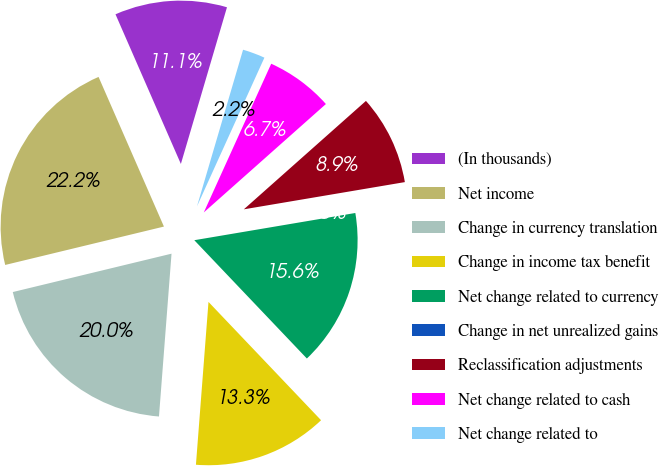Convert chart to OTSL. <chart><loc_0><loc_0><loc_500><loc_500><pie_chart><fcel>(In thousands)<fcel>Net income<fcel>Change in currency translation<fcel>Change in income tax benefit<fcel>Net change related to currency<fcel>Change in net unrealized gains<fcel>Reclassification adjustments<fcel>Net change related to cash<fcel>Net change related to<nl><fcel>11.11%<fcel>22.22%<fcel>20.0%<fcel>13.33%<fcel>15.56%<fcel>0.0%<fcel>8.89%<fcel>6.67%<fcel>2.22%<nl></chart> 